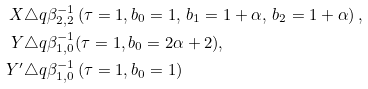Convert formula to latex. <formula><loc_0><loc_0><loc_500><loc_500>X & \triangle q \beta _ { 2 , 2 } ^ { - 1 } \left ( \tau = 1 , b _ { 0 } = 1 , \, b _ { 1 } = 1 + \alpha , \, b _ { 2 } = 1 + \alpha \right ) , \\ Y & \triangle q \beta _ { 1 , 0 } ^ { - 1 } ( \tau = 1 , b _ { 0 } = 2 \alpha + 2 ) , \\ Y ^ { \prime } & \triangle q \beta _ { 1 , 0 } ^ { - 1 } \left ( \tau = 1 , b _ { 0 } = 1 \right )</formula> 